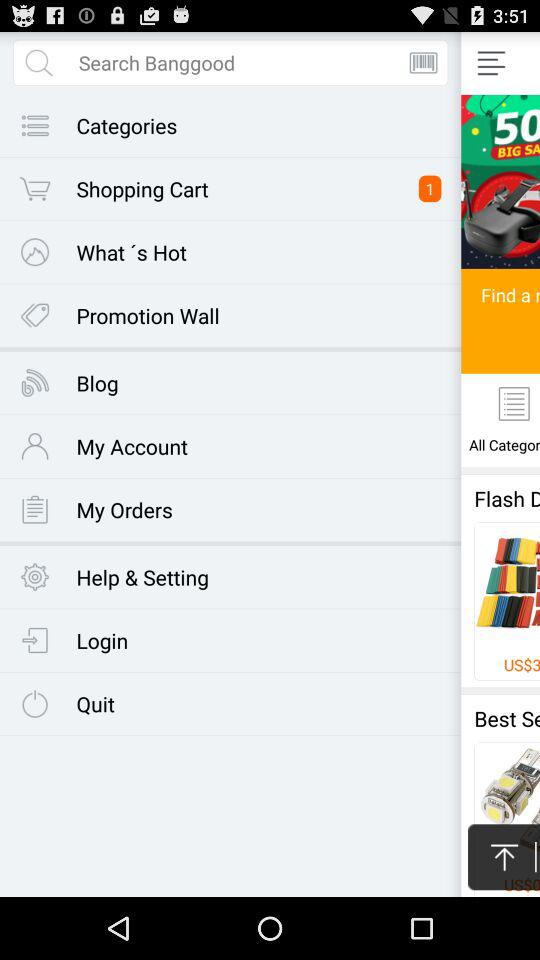What is the name of the product? The name of the product is "Bow Belt Solid Color Mesh Tulle Pleated High Waist Women Maxi Skirt". 